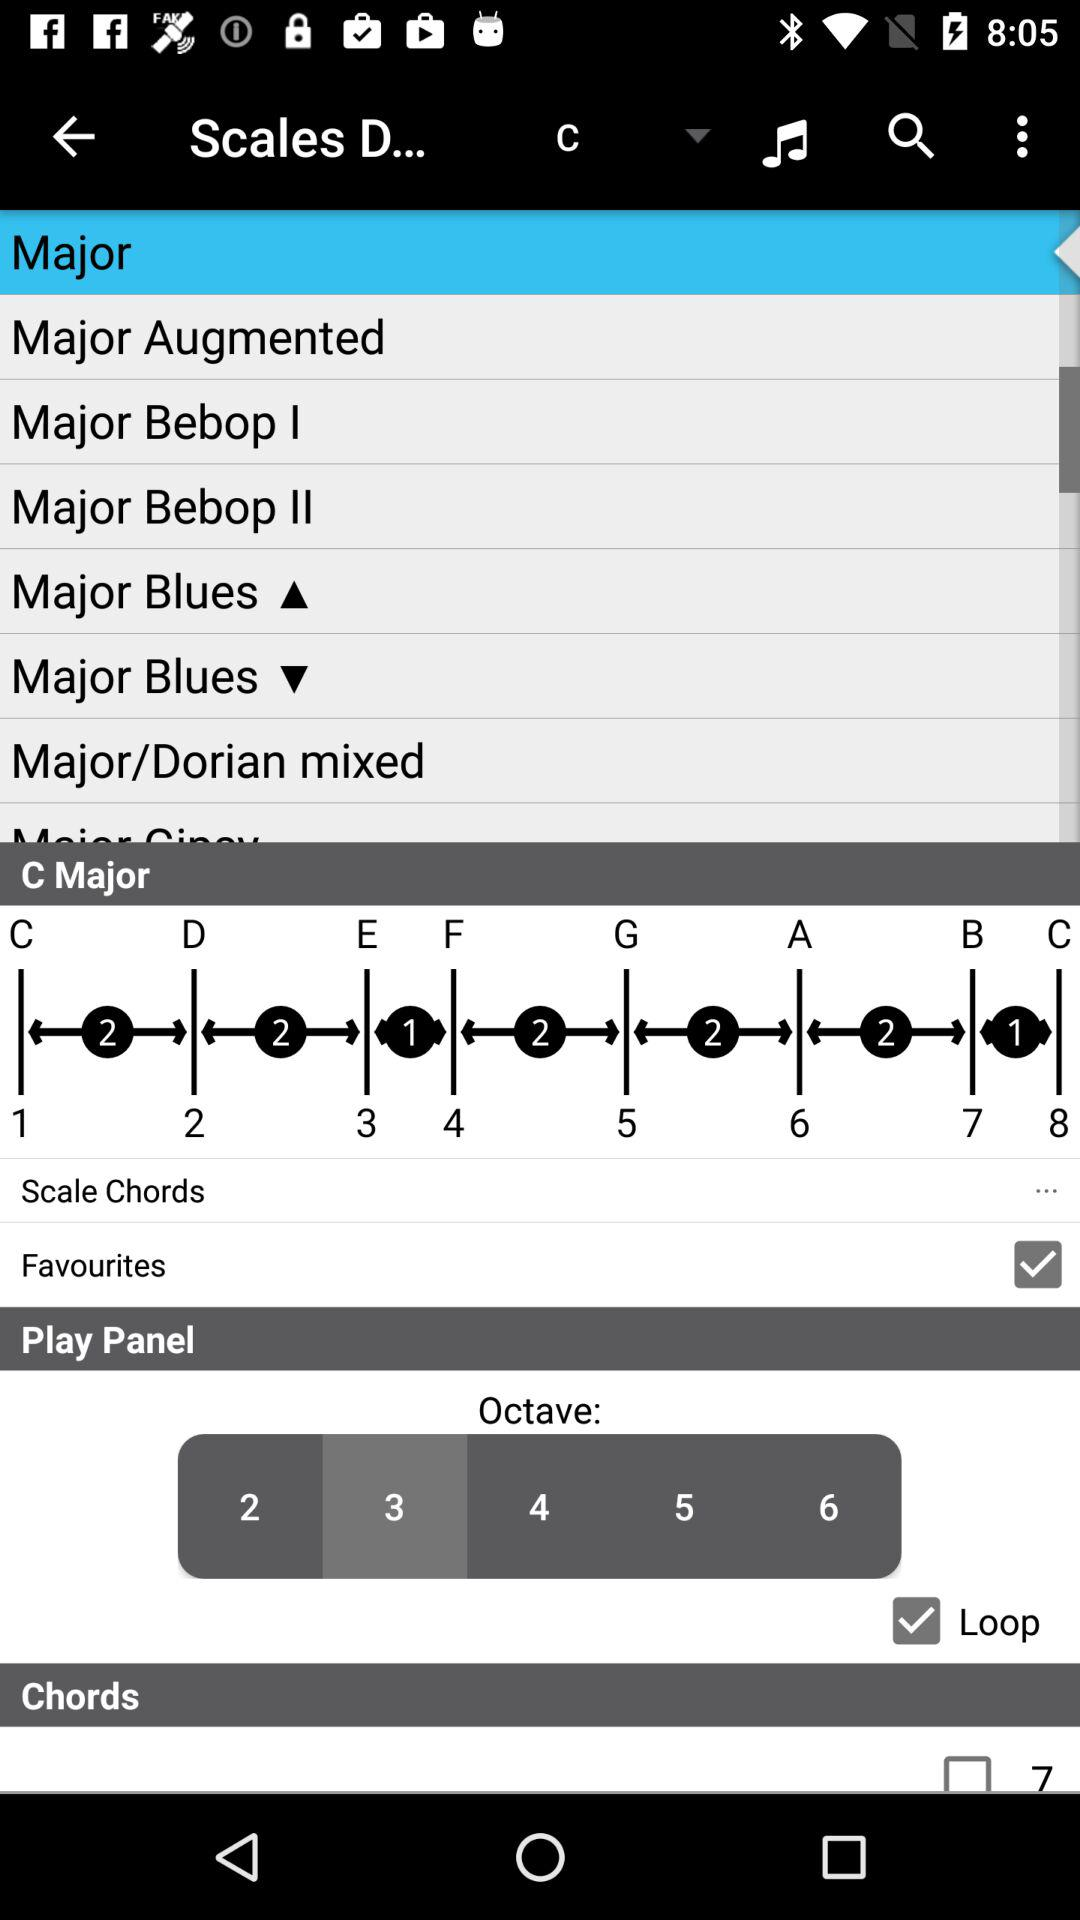What is the status of "Favourites"? The status is "on". 